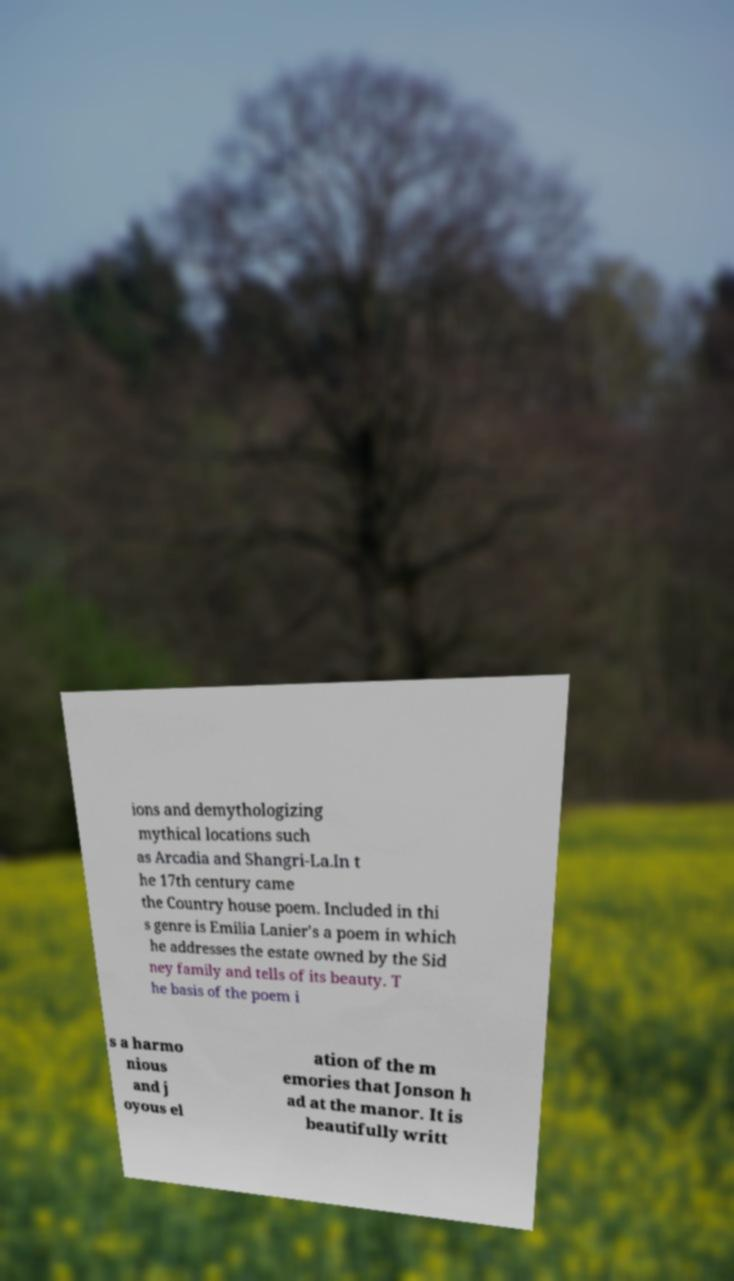Please identify and transcribe the text found in this image. ions and demythologizing mythical locations such as Arcadia and Shangri-La.In t he 17th century came the Country house poem. Included in thi s genre is Emilia Lanier's a poem in which he addresses the estate owned by the Sid ney family and tells of its beauty. T he basis of the poem i s a harmo nious and j oyous el ation of the m emories that Jonson h ad at the manor. It is beautifully writt 